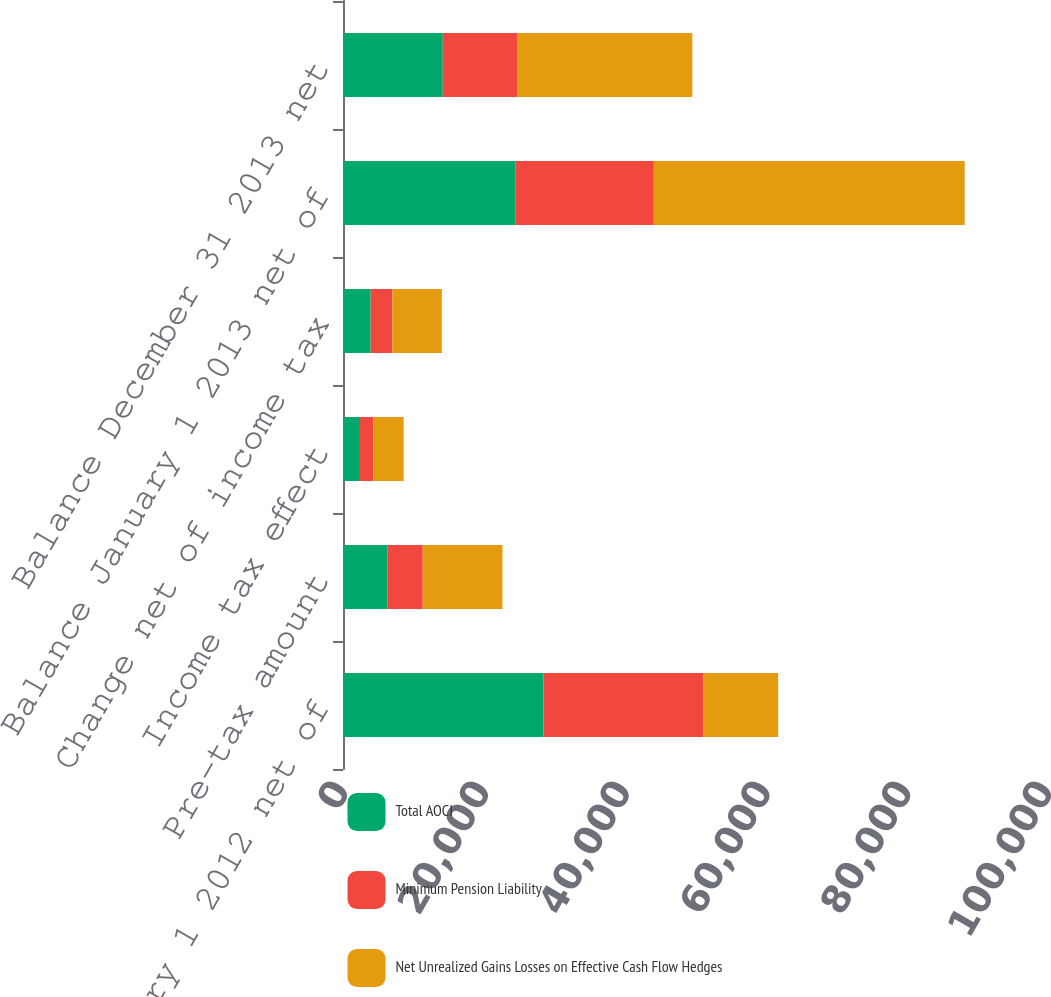Convert chart. <chart><loc_0><loc_0><loc_500><loc_500><stacked_bar_chart><ecel><fcel>Balance January 1 2012 net of<fcel>Pre-tax amount<fcel>Income tax effect<fcel>Change net of income tax<fcel>Balance January 1 2013 net of<fcel>Balance December 31 2013 net<nl><fcel>Total AOCI<fcel>28460<fcel>6341<fcel>2408<fcel>3933<fcel>24527<fcel>14170<nl><fcel>Minimum Pension Liability<fcel>22715<fcel>4986<fcel>1898<fcel>3088<fcel>19627<fcel>10640<nl><fcel>Net Unrealized Gains Losses on Effective Cash Flow Hedges<fcel>10640<fcel>11327<fcel>4306<fcel>7021<fcel>44154<fcel>24810<nl></chart> 